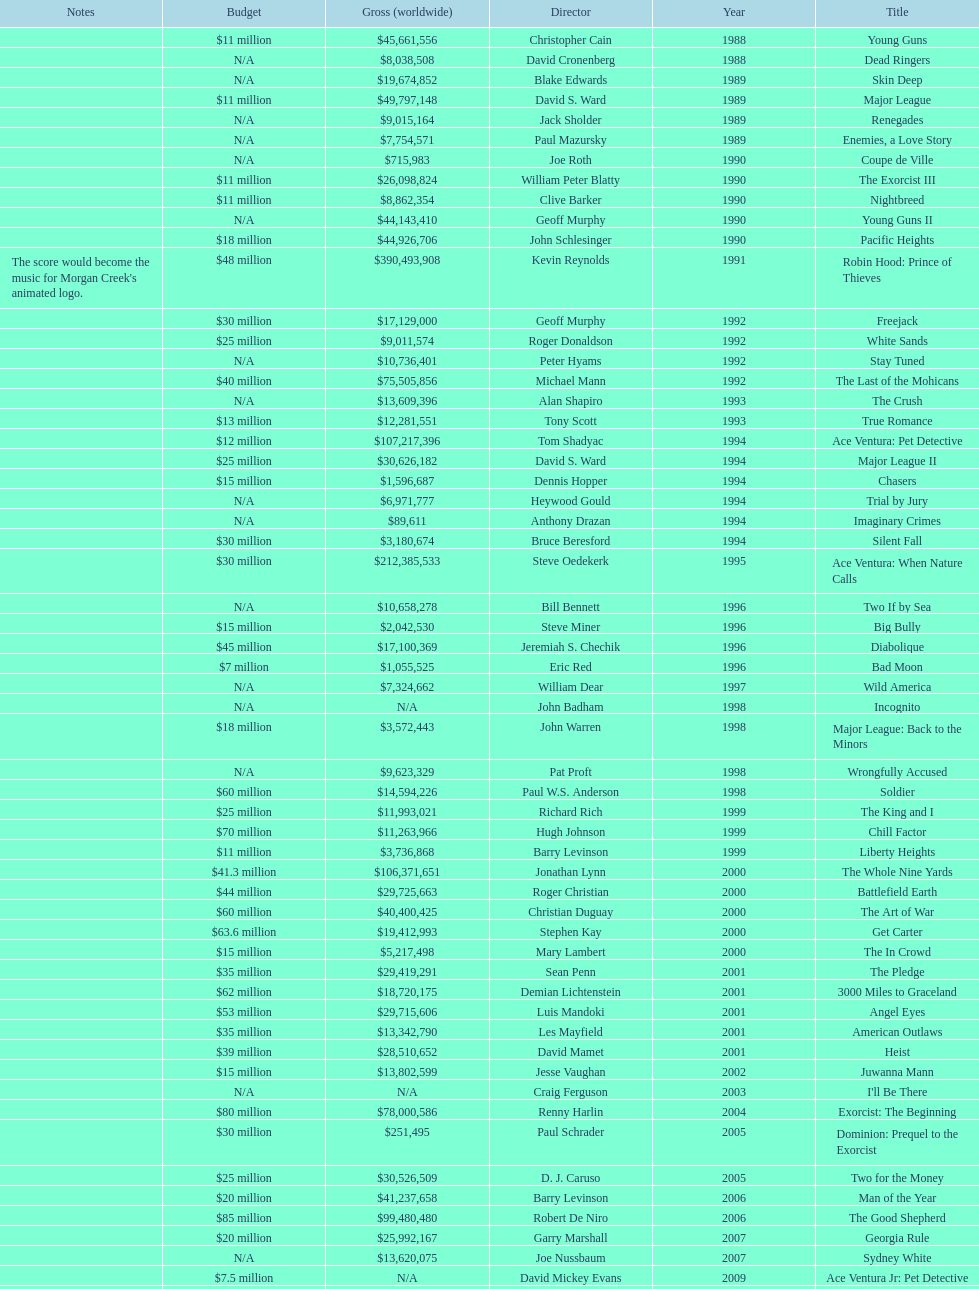Could you help me parse every detail presented in this table? {'header': ['Notes', 'Budget', 'Gross (worldwide)', 'Director', 'Year', 'Title'], 'rows': [['', '$11 million', '$45,661,556', 'Christopher Cain', '1988', 'Young Guns'], ['', 'N/A', '$8,038,508', 'David Cronenberg', '1988', 'Dead Ringers'], ['', 'N/A', '$19,674,852', 'Blake Edwards', '1989', 'Skin Deep'], ['', '$11 million', '$49,797,148', 'David S. Ward', '1989', 'Major League'], ['', 'N/A', '$9,015,164', 'Jack Sholder', '1989', 'Renegades'], ['', 'N/A', '$7,754,571', 'Paul Mazursky', '1989', 'Enemies, a Love Story'], ['', 'N/A', '$715,983', 'Joe Roth', '1990', 'Coupe de Ville'], ['', '$11 million', '$26,098,824', 'William Peter Blatty', '1990', 'The Exorcist III'], ['', '$11 million', '$8,862,354', 'Clive Barker', '1990', 'Nightbreed'], ['', 'N/A', '$44,143,410', 'Geoff Murphy', '1990', 'Young Guns II'], ['', '$18 million', '$44,926,706', 'John Schlesinger', '1990', 'Pacific Heights'], ["The score would become the music for Morgan Creek's animated logo.", '$48 million', '$390,493,908', 'Kevin Reynolds', '1991', 'Robin Hood: Prince of Thieves'], ['', '$30 million', '$17,129,000', 'Geoff Murphy', '1992', 'Freejack'], ['', '$25 million', '$9,011,574', 'Roger Donaldson', '1992', 'White Sands'], ['', 'N/A', '$10,736,401', 'Peter Hyams', '1992', 'Stay Tuned'], ['', '$40 million', '$75,505,856', 'Michael Mann', '1992', 'The Last of the Mohicans'], ['', 'N/A', '$13,609,396', 'Alan Shapiro', '1993', 'The Crush'], ['', '$13 million', '$12,281,551', 'Tony Scott', '1993', 'True Romance'], ['', '$12 million', '$107,217,396', 'Tom Shadyac', '1994', 'Ace Ventura: Pet Detective'], ['', '$25 million', '$30,626,182', 'David S. Ward', '1994', 'Major League II'], ['', '$15 million', '$1,596,687', 'Dennis Hopper', '1994', 'Chasers'], ['', 'N/A', '$6,971,777', 'Heywood Gould', '1994', 'Trial by Jury'], ['', 'N/A', '$89,611', 'Anthony Drazan', '1994', 'Imaginary Crimes'], ['', '$30 million', '$3,180,674', 'Bruce Beresford', '1994', 'Silent Fall'], ['', '$30 million', '$212,385,533', 'Steve Oedekerk', '1995', 'Ace Ventura: When Nature Calls'], ['', 'N/A', '$10,658,278', 'Bill Bennett', '1996', 'Two If by Sea'], ['', '$15 million', '$2,042,530', 'Steve Miner', '1996', 'Big Bully'], ['', '$45 million', '$17,100,369', 'Jeremiah S. Chechik', '1996', 'Diabolique'], ['', '$7 million', '$1,055,525', 'Eric Red', '1996', 'Bad Moon'], ['', 'N/A', '$7,324,662', 'William Dear', '1997', 'Wild America'], ['', 'N/A', 'N/A', 'John Badham', '1998', 'Incognito'], ['', '$18 million', '$3,572,443', 'John Warren', '1998', 'Major League: Back to the Minors'], ['', 'N/A', '$9,623,329', 'Pat Proft', '1998', 'Wrongfully Accused'], ['', '$60 million', '$14,594,226', 'Paul W.S. Anderson', '1998', 'Soldier'], ['', '$25 million', '$11,993,021', 'Richard Rich', '1999', 'The King and I'], ['', '$70 million', '$11,263,966', 'Hugh Johnson', '1999', 'Chill Factor'], ['', '$11 million', '$3,736,868', 'Barry Levinson', '1999', 'Liberty Heights'], ['', '$41.3 million', '$106,371,651', 'Jonathan Lynn', '2000', 'The Whole Nine Yards'], ['', '$44 million', '$29,725,663', 'Roger Christian', '2000', 'Battlefield Earth'], ['', '$60 million', '$40,400,425', 'Christian Duguay', '2000', 'The Art of War'], ['', '$63.6 million', '$19,412,993', 'Stephen Kay', '2000', 'Get Carter'], ['', '$15 million', '$5,217,498', 'Mary Lambert', '2000', 'The In Crowd'], ['', '$35 million', '$29,419,291', 'Sean Penn', '2001', 'The Pledge'], ['', '$62 million', '$18,720,175', 'Demian Lichtenstein', '2001', '3000 Miles to Graceland'], ['', '$53 million', '$29,715,606', 'Luis Mandoki', '2001', 'Angel Eyes'], ['', '$35 million', '$13,342,790', 'Les Mayfield', '2001', 'American Outlaws'], ['', '$39 million', '$28,510,652', 'David Mamet', '2001', 'Heist'], ['', '$15 million', '$13,802,599', 'Jesse Vaughan', '2002', 'Juwanna Mann'], ['', 'N/A', 'N/A', 'Craig Ferguson', '2003', "I'll Be There"], ['', '$80 million', '$78,000,586', 'Renny Harlin', '2004', 'Exorcist: The Beginning'], ['', '$30 million', '$251,495', 'Paul Schrader', '2005', 'Dominion: Prequel to the Exorcist'], ['', '$25 million', '$30,526,509', 'D. J. Caruso', '2005', 'Two for the Money'], ['', '$20 million', '$41,237,658', 'Barry Levinson', '2006', 'Man of the Year'], ['', '$85 million', '$99,480,480', 'Robert De Niro', '2006', 'The Good Shepherd'], ['', '$20 million', '$25,992,167', 'Garry Marshall', '2007', 'Georgia Rule'], ['', 'N/A', '$13,620,075', 'Joe Nussbaum', '2007', 'Sydney White'], ['', '$7.5 million', 'N/A', 'David Mickey Evans', '2009', 'Ace Ventura Jr: Pet Detective'], ['', '$50 million', '$38,502,340', 'Jim Sheridan', '2011', 'Dream House'], ['', '$38 million', '$27,428,670', 'Matthijs van Heijningen Jr.', '2011', 'The Thing'], ['', '$45 million', '', 'Antoine Fuqua', '2014', 'Tupac']]} What is the top grossing film? Robin Hood: Prince of Thieves. 